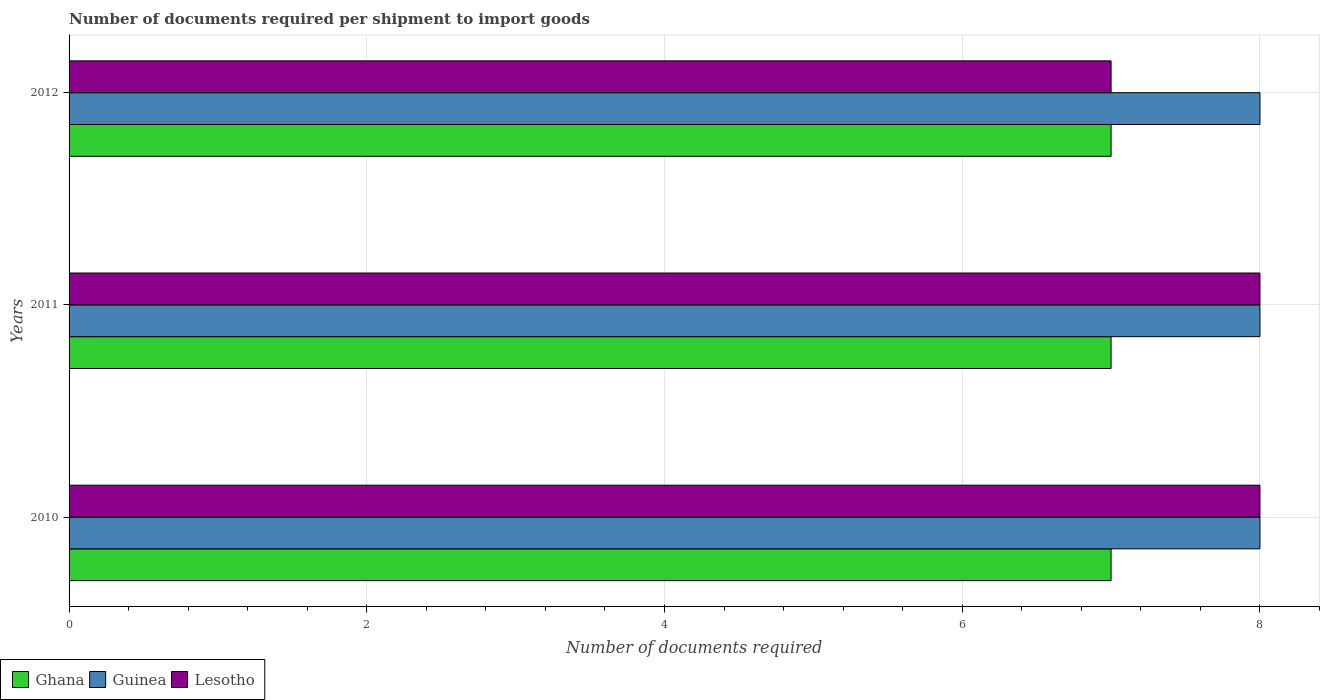How many different coloured bars are there?
Your answer should be very brief. 3. How many groups of bars are there?
Keep it short and to the point. 3. Are the number of bars per tick equal to the number of legend labels?
Ensure brevity in your answer.  Yes. Are the number of bars on each tick of the Y-axis equal?
Ensure brevity in your answer.  Yes. How many bars are there on the 3rd tick from the top?
Provide a succinct answer. 3. How many bars are there on the 2nd tick from the bottom?
Provide a succinct answer. 3. What is the label of the 3rd group of bars from the top?
Provide a succinct answer. 2010. What is the number of documents required per shipment to import goods in Lesotho in 2010?
Offer a very short reply. 8. Across all years, what is the maximum number of documents required per shipment to import goods in Lesotho?
Your answer should be compact. 8. Across all years, what is the minimum number of documents required per shipment to import goods in Ghana?
Provide a short and direct response. 7. In which year was the number of documents required per shipment to import goods in Ghana maximum?
Your answer should be compact. 2010. What is the total number of documents required per shipment to import goods in Lesotho in the graph?
Offer a very short reply. 23. What is the difference between the number of documents required per shipment to import goods in Guinea in 2010 and the number of documents required per shipment to import goods in Ghana in 2012?
Keep it short and to the point. 1. What is the average number of documents required per shipment to import goods in Lesotho per year?
Provide a short and direct response. 7.67. In the year 2012, what is the difference between the number of documents required per shipment to import goods in Lesotho and number of documents required per shipment to import goods in Guinea?
Your response must be concise. -1. What is the difference between the highest and the second highest number of documents required per shipment to import goods in Ghana?
Offer a terse response. 0. What is the difference between the highest and the lowest number of documents required per shipment to import goods in Guinea?
Offer a terse response. 0. In how many years, is the number of documents required per shipment to import goods in Ghana greater than the average number of documents required per shipment to import goods in Ghana taken over all years?
Make the answer very short. 0. What does the 3rd bar from the top in 2012 represents?
Provide a short and direct response. Ghana. Is it the case that in every year, the sum of the number of documents required per shipment to import goods in Lesotho and number of documents required per shipment to import goods in Ghana is greater than the number of documents required per shipment to import goods in Guinea?
Keep it short and to the point. Yes. Are the values on the major ticks of X-axis written in scientific E-notation?
Offer a very short reply. No. What is the title of the graph?
Ensure brevity in your answer.  Number of documents required per shipment to import goods. What is the label or title of the X-axis?
Provide a short and direct response. Number of documents required. What is the label or title of the Y-axis?
Make the answer very short. Years. What is the Number of documents required of Ghana in 2010?
Your answer should be very brief. 7. What is the Number of documents required in Lesotho in 2010?
Ensure brevity in your answer.  8. What is the Number of documents required of Ghana in 2011?
Offer a terse response. 7. What is the Number of documents required of Guinea in 2011?
Provide a succinct answer. 8. What is the Number of documents required in Lesotho in 2011?
Your response must be concise. 8. What is the Number of documents required in Ghana in 2012?
Make the answer very short. 7. Across all years, what is the maximum Number of documents required of Guinea?
Your answer should be compact. 8. Across all years, what is the minimum Number of documents required in Ghana?
Keep it short and to the point. 7. What is the total Number of documents required of Ghana in the graph?
Keep it short and to the point. 21. What is the total Number of documents required of Guinea in the graph?
Keep it short and to the point. 24. What is the difference between the Number of documents required of Ghana in 2010 and that in 2011?
Offer a very short reply. 0. What is the difference between the Number of documents required in Ghana in 2010 and that in 2012?
Ensure brevity in your answer.  0. What is the difference between the Number of documents required of Guinea in 2010 and that in 2012?
Give a very brief answer. 0. What is the difference between the Number of documents required in Lesotho in 2010 and that in 2012?
Ensure brevity in your answer.  1. What is the difference between the Number of documents required in Ghana in 2011 and that in 2012?
Make the answer very short. 0. What is the difference between the Number of documents required in Guinea in 2010 and the Number of documents required in Lesotho in 2011?
Provide a succinct answer. 0. What is the difference between the Number of documents required in Ghana in 2010 and the Number of documents required in Guinea in 2012?
Provide a succinct answer. -1. What is the difference between the Number of documents required in Ghana in 2011 and the Number of documents required in Lesotho in 2012?
Provide a short and direct response. 0. What is the difference between the Number of documents required of Guinea in 2011 and the Number of documents required of Lesotho in 2012?
Offer a terse response. 1. What is the average Number of documents required in Guinea per year?
Give a very brief answer. 8. What is the average Number of documents required of Lesotho per year?
Your answer should be compact. 7.67. In the year 2010, what is the difference between the Number of documents required in Ghana and Number of documents required in Guinea?
Provide a short and direct response. -1. In the year 2010, what is the difference between the Number of documents required in Guinea and Number of documents required in Lesotho?
Provide a short and direct response. 0. In the year 2011, what is the difference between the Number of documents required in Ghana and Number of documents required in Guinea?
Offer a terse response. -1. In the year 2011, what is the difference between the Number of documents required in Ghana and Number of documents required in Lesotho?
Provide a short and direct response. -1. In the year 2011, what is the difference between the Number of documents required of Guinea and Number of documents required of Lesotho?
Your answer should be compact. 0. In the year 2012, what is the difference between the Number of documents required of Ghana and Number of documents required of Guinea?
Offer a terse response. -1. In the year 2012, what is the difference between the Number of documents required in Guinea and Number of documents required in Lesotho?
Provide a short and direct response. 1. What is the ratio of the Number of documents required in Ghana in 2010 to that in 2011?
Provide a short and direct response. 1. What is the ratio of the Number of documents required of Lesotho in 2010 to that in 2011?
Your answer should be very brief. 1. What is the ratio of the Number of documents required in Ghana in 2010 to that in 2012?
Provide a short and direct response. 1. What is the ratio of the Number of documents required in Guinea in 2010 to that in 2012?
Ensure brevity in your answer.  1. What is the ratio of the Number of documents required in Lesotho in 2010 to that in 2012?
Your answer should be compact. 1.14. What is the difference between the highest and the second highest Number of documents required in Lesotho?
Your response must be concise. 0. What is the difference between the highest and the lowest Number of documents required in Guinea?
Provide a short and direct response. 0. What is the difference between the highest and the lowest Number of documents required in Lesotho?
Ensure brevity in your answer.  1. 